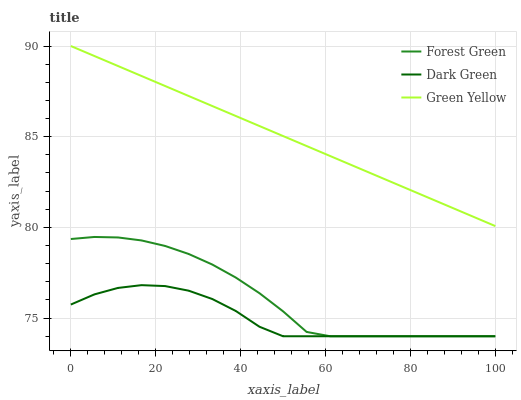Does Green Yellow have the minimum area under the curve?
Answer yes or no. No. Does Dark Green have the maximum area under the curve?
Answer yes or no. No. Is Dark Green the smoothest?
Answer yes or no. No. Is Dark Green the roughest?
Answer yes or no. No. Does Green Yellow have the lowest value?
Answer yes or no. No. Does Dark Green have the highest value?
Answer yes or no. No. Is Forest Green less than Green Yellow?
Answer yes or no. Yes. Is Green Yellow greater than Dark Green?
Answer yes or no. Yes. Does Forest Green intersect Green Yellow?
Answer yes or no. No. 